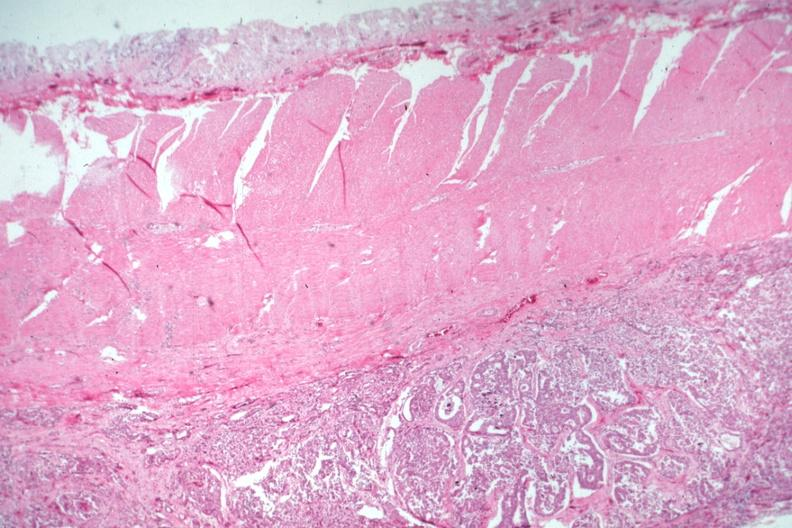what does this image show?
Answer the question using a single word or phrase. Carcinoma on peritoneal side of muscularis 